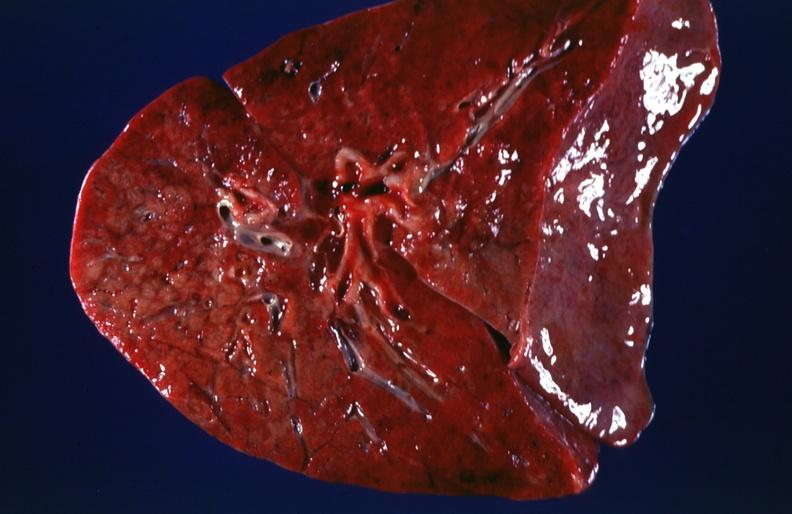where is this?
Answer the question using a single word or phrase. Lung 